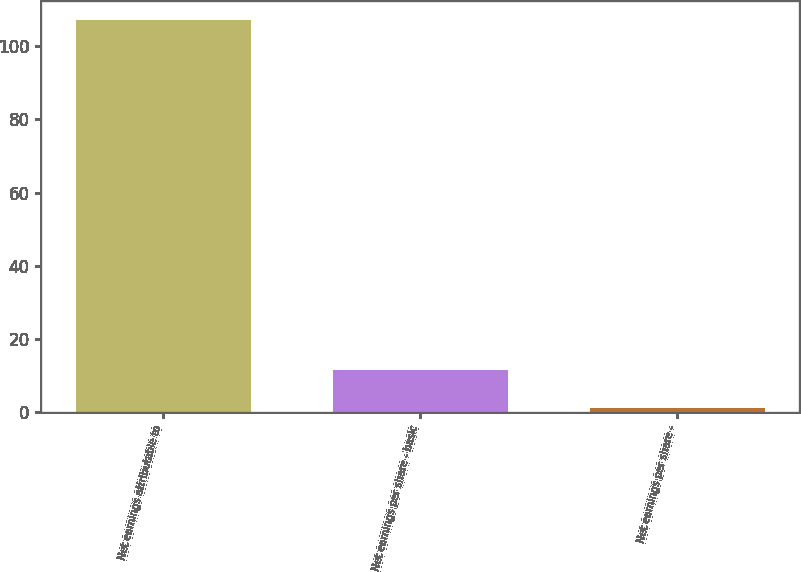<chart> <loc_0><loc_0><loc_500><loc_500><bar_chart><fcel>Net earnings attributable to<fcel>Net earnings per share - basic<fcel>Net earnings per share -<nl><fcel>107.1<fcel>11.63<fcel>1.02<nl></chart> 